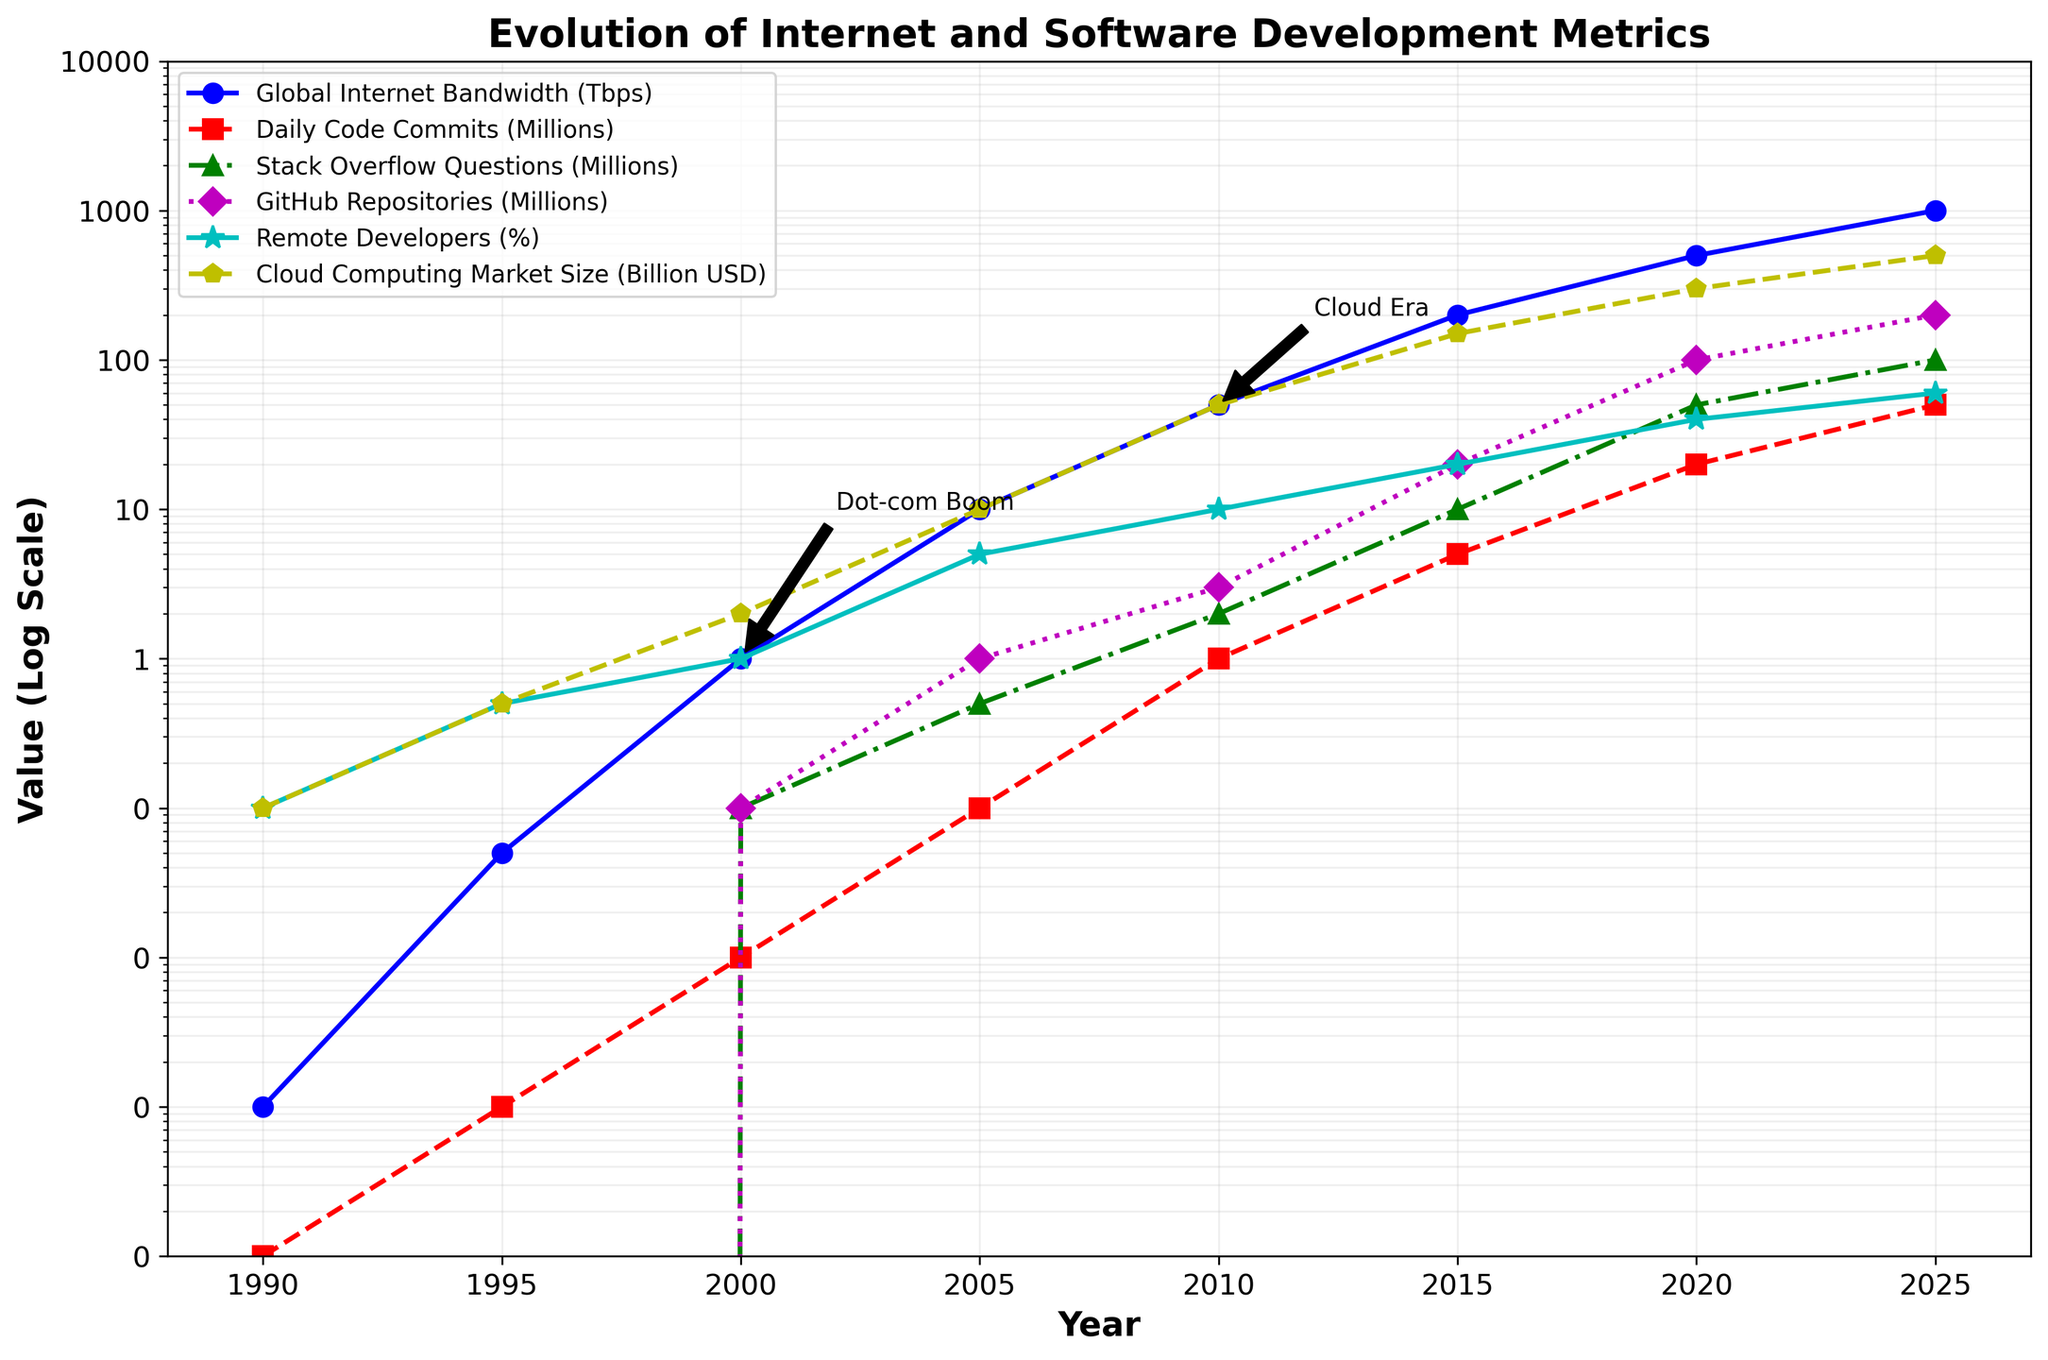What was the global internet bandwidth in 2000, and how much did it increase by 2005? The figure shows that global internet bandwidth in 2000 was 1 Tbps and in 2005 it was 10 Tbps. The increase is calculated by subtracting 1 Tbps from 10 Tbps.
Answer: 9 Tbps Comparing 2020 and 2025, which metric saw the largest proportional growth: global internet bandwidth, daily code commits, or cloud computing market size? To find the proportional growth, we need to divide the value in 2025 by the value in 2020 for each metric. For global internet bandwidth, it is 1000/500 = 2; for daily code commits, it is 50/20 = 2.5; for cloud computing market size, it is 500/300 = 1.67. Daily code commits saw the largest growth.
Answer: Daily code commits What trend can you observe about the percentage of remote developers between 2000 and 2025? The percentage of remote developers steadily increased from 1% in 2000 to 60% in 2025. Observing the plot, we see a consistent upward trend.
Answer: Steady increase Which metric experienced the sharpest spike between consecutive data points, and between which years did this occur? By observing the steepness of the lines and the annotations on the plot, the cloud computing market shows the sharpest spike between 2010 (50 Billion USD) and 2015 (150 Billion USD).
Answer: Cloud computing market, between 2010 and 2015 Can you identify two key historical points annotated in the figure, and briefly describe their significance? The figure annotates 'Dot-com Boom' near the year 2000 and 'Cloud Era' near 2010. The 'Dot-com Boom' was a period of rapid internet growth and investment in tech companies, while the 'Cloud Era' marks the expansion of cloud computing services.
Answer: Dot-com Boom (2000), Cloud Era (2010) By how much did the number of GitHub repositories increase from 2010 to 2020, and what is the average annual growth rate over that period? From the figure, the number of GitHub repositories increased from 3 million in 2010 to 100 million in 2020. The increase is 100 - 3 = 97 million over 10 years. The average annual growth rate is 97 million / 10 = 9.7 million.
Answer: 97 million, 9.7 million per year Which metric shows the least growth from 2015 to 2020? By observing the slopes of the lines from 2015 to 2020, the number of Stack Overflow questions grows from 10 million to 50 million, which seems relatively less pronounced than the growth in other metrics like daily code commits or cloud computing market.
Answer: Stack Overflow questions What is the relationship between remote developers' percentage and cloud computing market size from 1990 to 2025? Both metrics exhibit an increasing trend over the years. The percentage of remote developers and cloud computing market size both show rapid growth, especially post-2010, reflecting a correlation where more remote work may drive higher cloud computing demand.
Answer: Both increase Which year corresponds to the highest daily code commits according to the figure? According to the plot, the highest daily code commits occurred in 2025, reaching 50 million.
Answer: 2025 